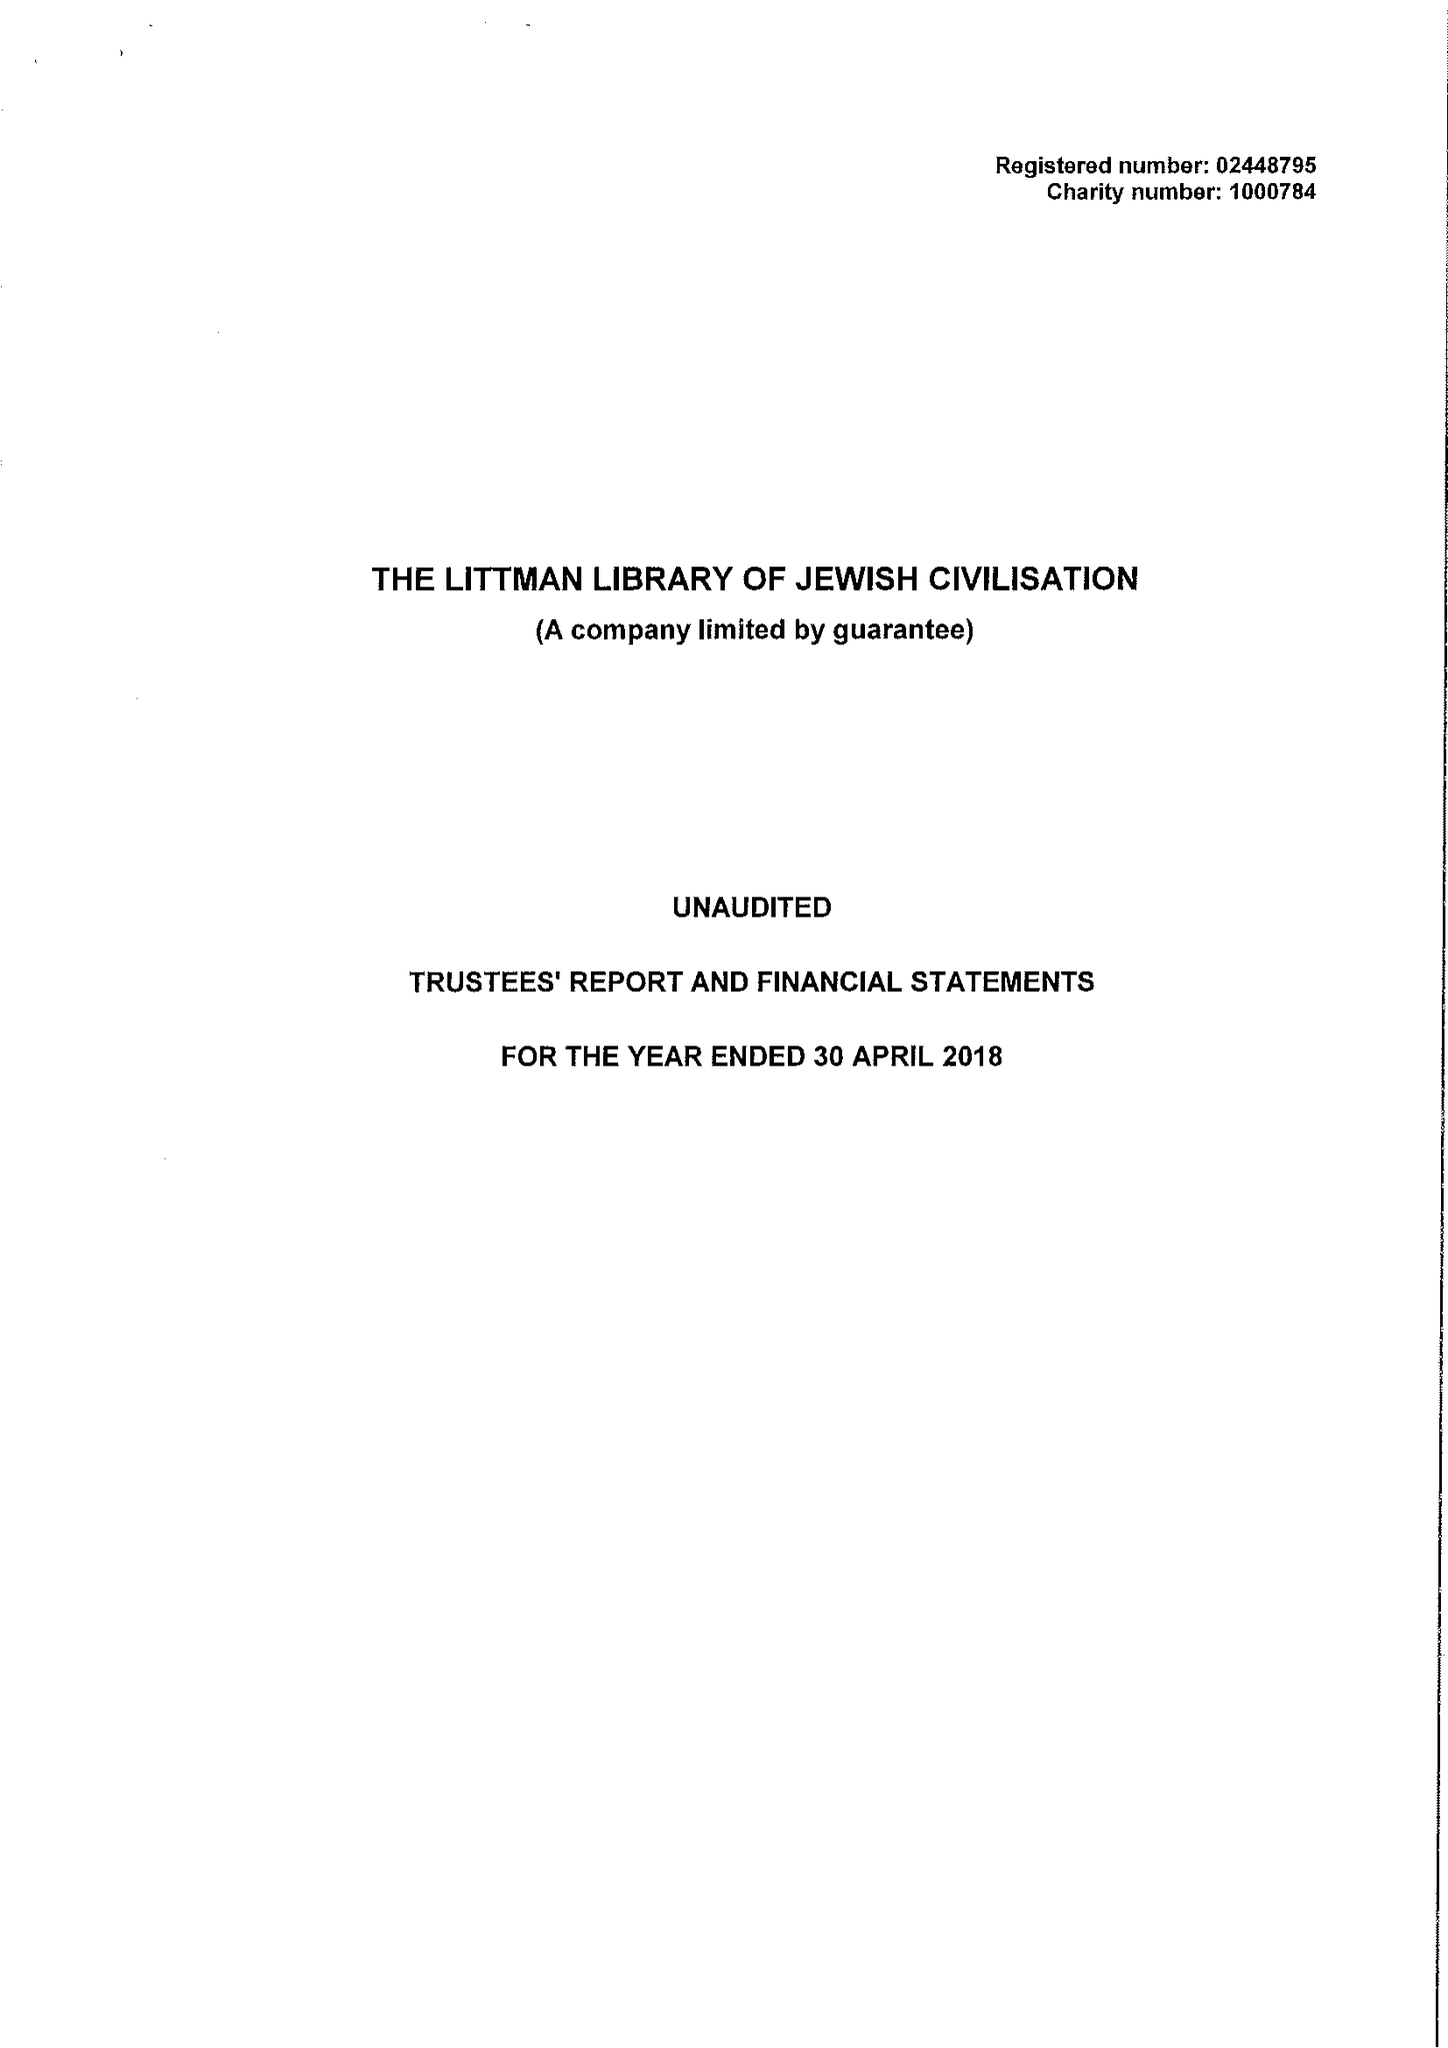What is the value for the address__street_line?
Answer the question using a single word or phrase. None 